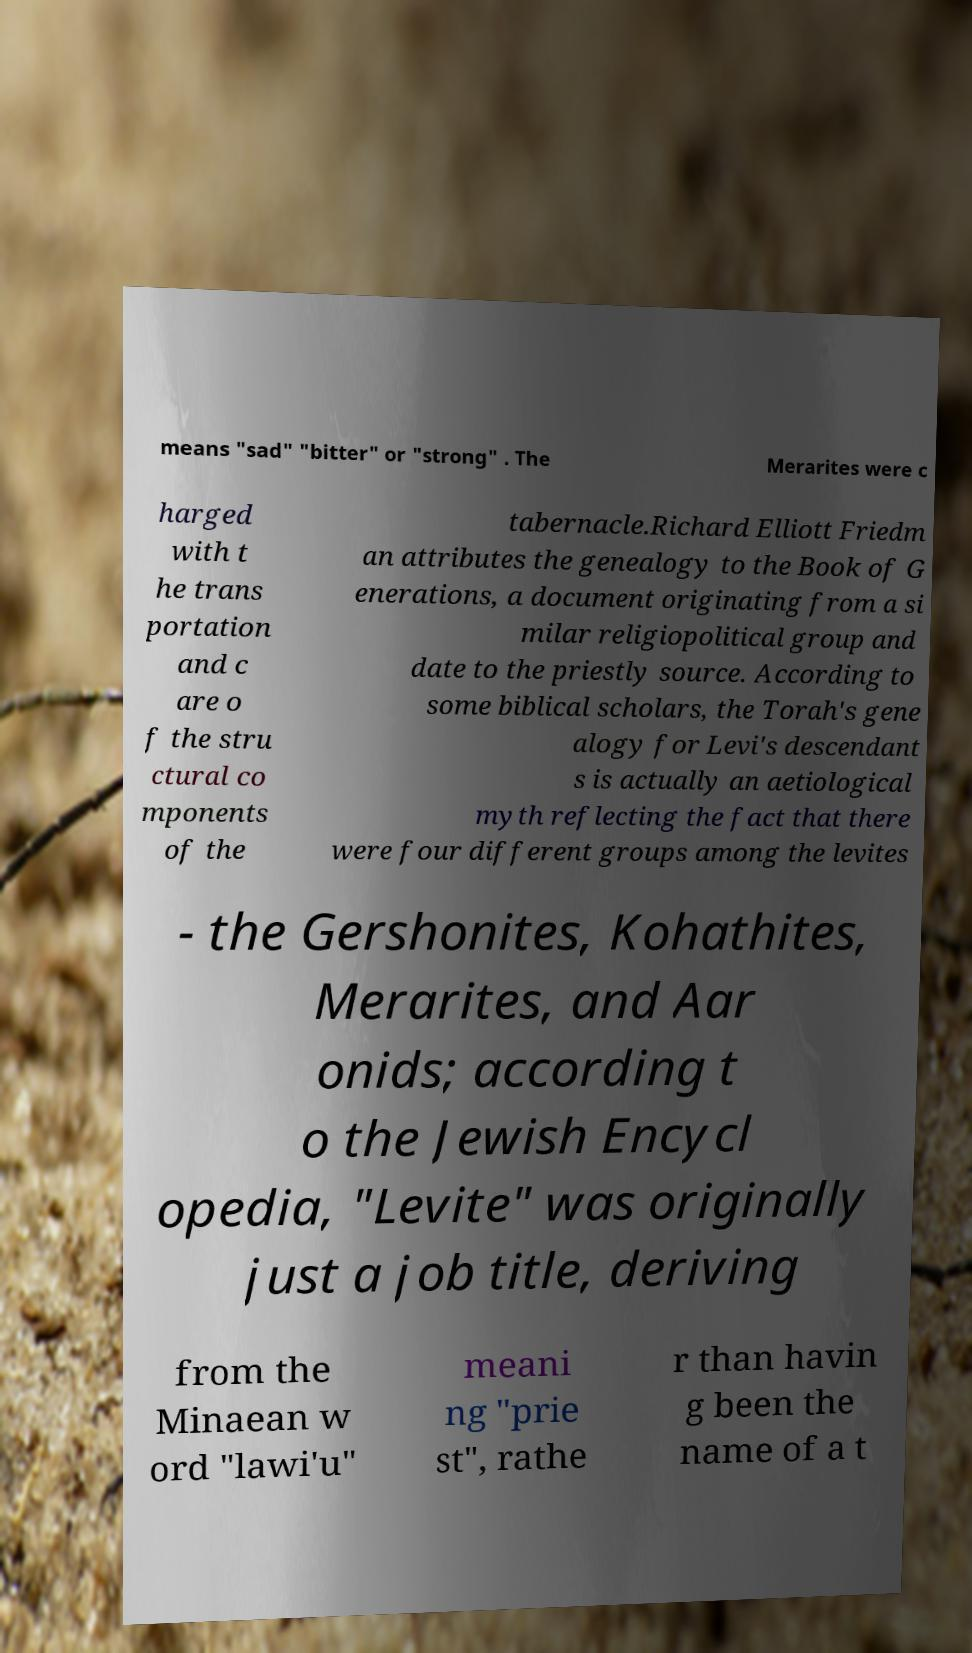For documentation purposes, I need the text within this image transcribed. Could you provide that? means "sad" "bitter" or "strong" . The Merarites were c harged with t he trans portation and c are o f the stru ctural co mponents of the tabernacle.Richard Elliott Friedm an attributes the genealogy to the Book of G enerations, a document originating from a si milar religiopolitical group and date to the priestly source. According to some biblical scholars, the Torah's gene alogy for Levi's descendant s is actually an aetiological myth reflecting the fact that there were four different groups among the levites - the Gershonites, Kohathites, Merarites, and Aar onids; according t o the Jewish Encycl opedia, "Levite" was originally just a job title, deriving from the Minaean w ord "lawi'u" meani ng "prie st", rathe r than havin g been the name of a t 